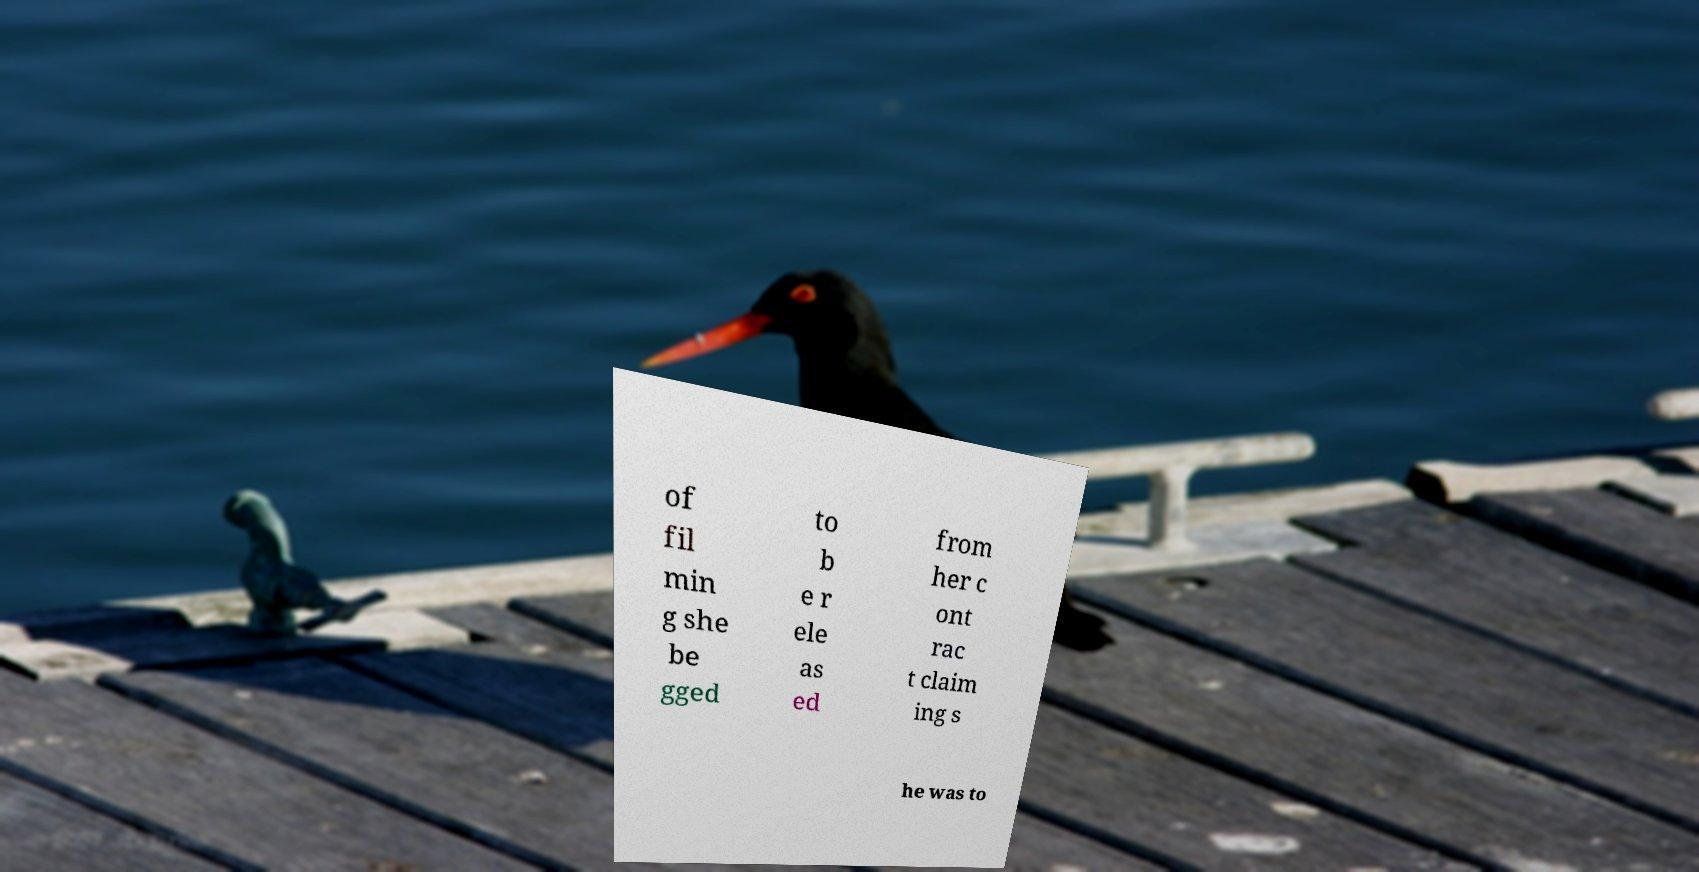Please identify and transcribe the text found in this image. of fil min g she be gged to b e r ele as ed from her c ont rac t claim ing s he was to 